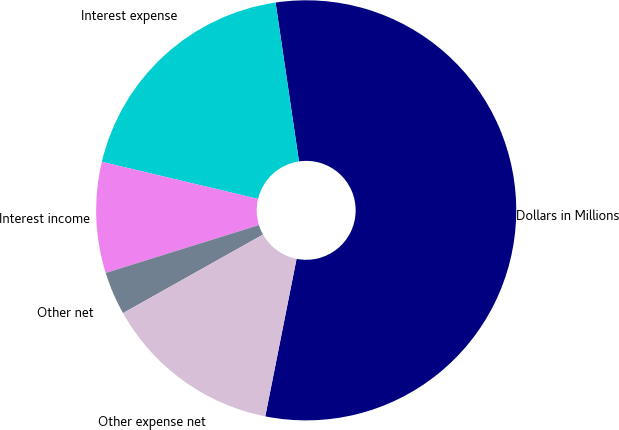Convert chart to OTSL. <chart><loc_0><loc_0><loc_500><loc_500><pie_chart><fcel>Dollars in Millions<fcel>Interest expense<fcel>Interest income<fcel>Other net<fcel>Other expense net<nl><fcel>55.45%<fcel>18.96%<fcel>8.53%<fcel>3.32%<fcel>13.74%<nl></chart> 